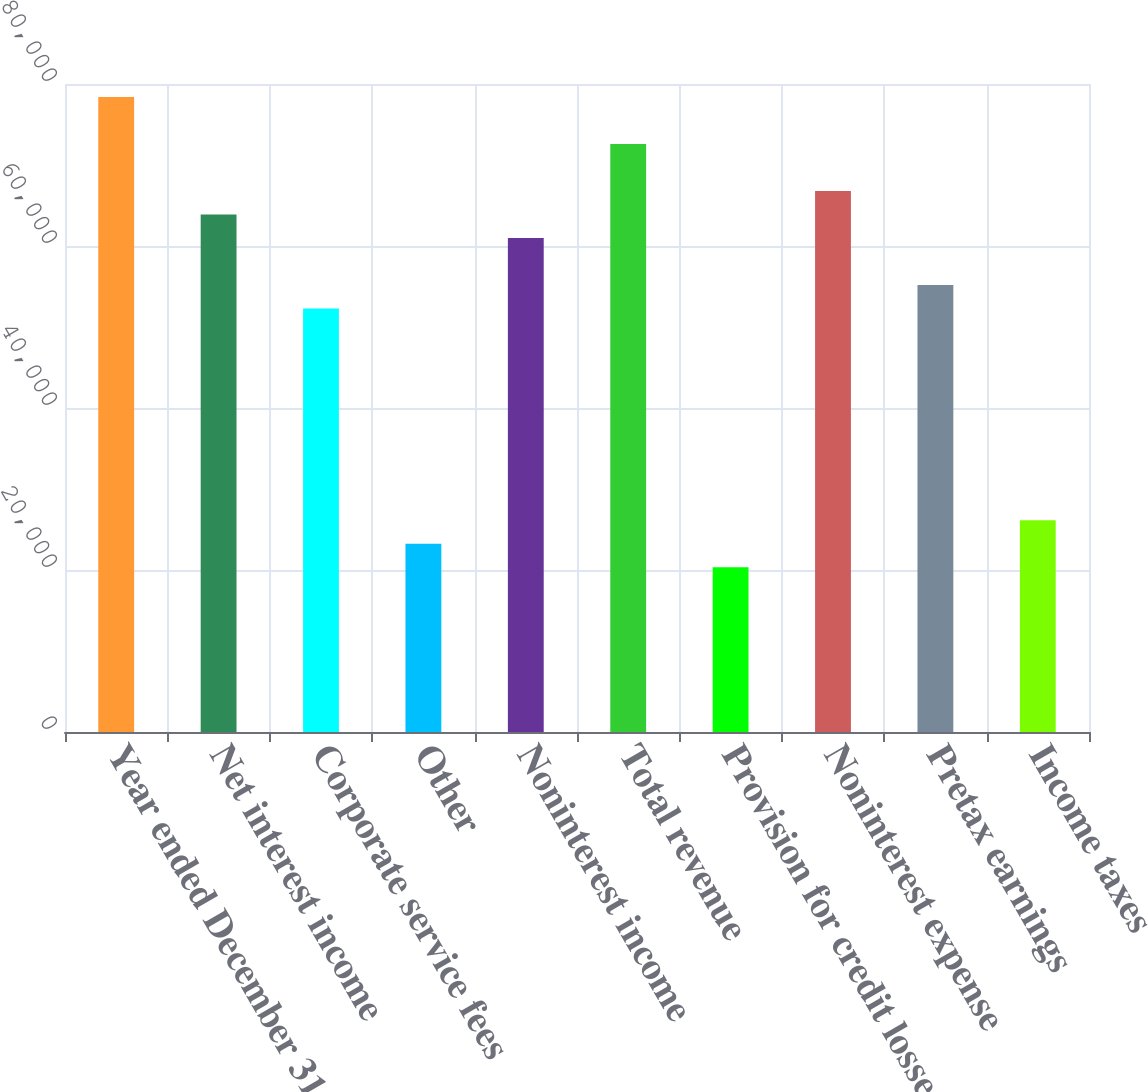<chart> <loc_0><loc_0><loc_500><loc_500><bar_chart><fcel>Year ended December 31 Dollars<fcel>Net interest income<fcel>Corporate service fees<fcel>Other<fcel>Noninterest income<fcel>Total revenue<fcel>Provision for credit losses<fcel>Noninterest expense<fcel>Pretax earnings<fcel>Income taxes<nl><fcel>78408.1<fcel>63891.6<fcel>52278.4<fcel>23245.4<fcel>60988.3<fcel>72601.5<fcel>20342.1<fcel>66794.9<fcel>55181.7<fcel>26148.7<nl></chart> 